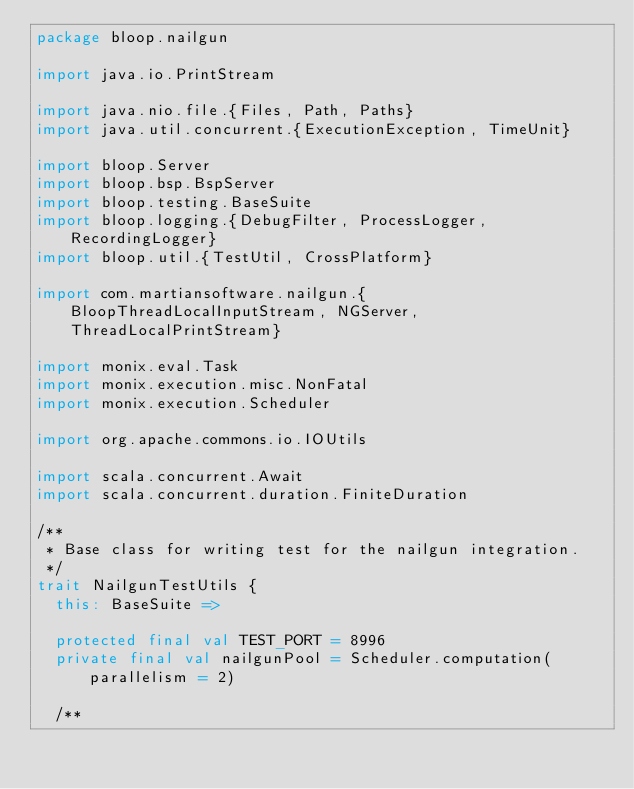Convert code to text. <code><loc_0><loc_0><loc_500><loc_500><_Scala_>package bloop.nailgun

import java.io.PrintStream

import java.nio.file.{Files, Path, Paths}
import java.util.concurrent.{ExecutionException, TimeUnit}

import bloop.Server
import bloop.bsp.BspServer
import bloop.testing.BaseSuite
import bloop.logging.{DebugFilter, ProcessLogger, RecordingLogger}
import bloop.util.{TestUtil, CrossPlatform}

import com.martiansoftware.nailgun.{BloopThreadLocalInputStream, NGServer, ThreadLocalPrintStream}

import monix.eval.Task
import monix.execution.misc.NonFatal
import monix.execution.Scheduler

import org.apache.commons.io.IOUtils

import scala.concurrent.Await
import scala.concurrent.duration.FiniteDuration

/**
 * Base class for writing test for the nailgun integration.
 */
trait NailgunTestUtils {
  this: BaseSuite =>

  protected final val TEST_PORT = 8996
  private final val nailgunPool = Scheduler.computation(parallelism = 2)

  /**</code> 